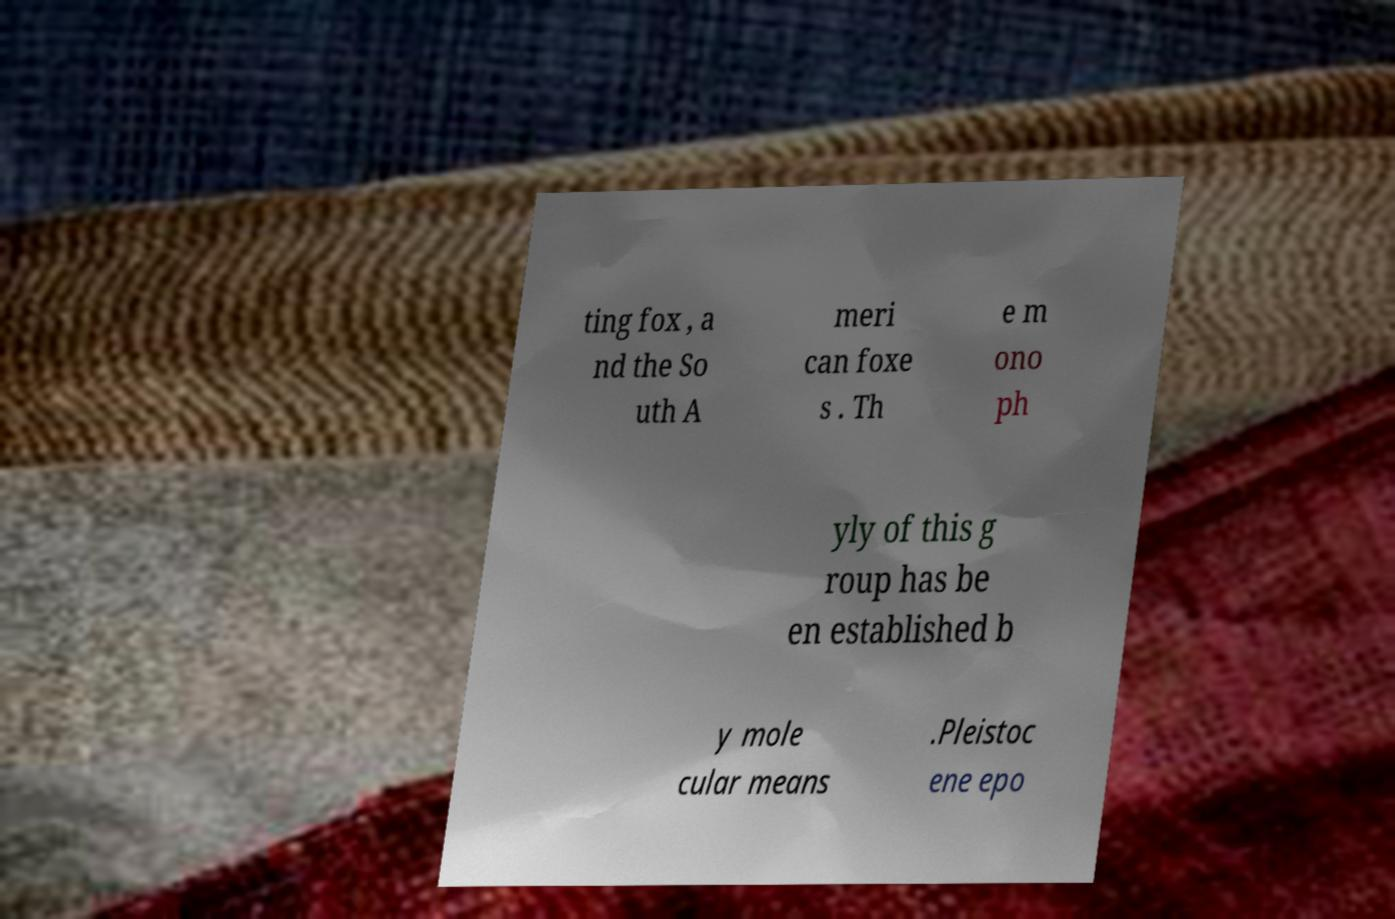Can you accurately transcribe the text from the provided image for me? ting fox , a nd the So uth A meri can foxe s . Th e m ono ph yly of this g roup has be en established b y mole cular means .Pleistoc ene epo 